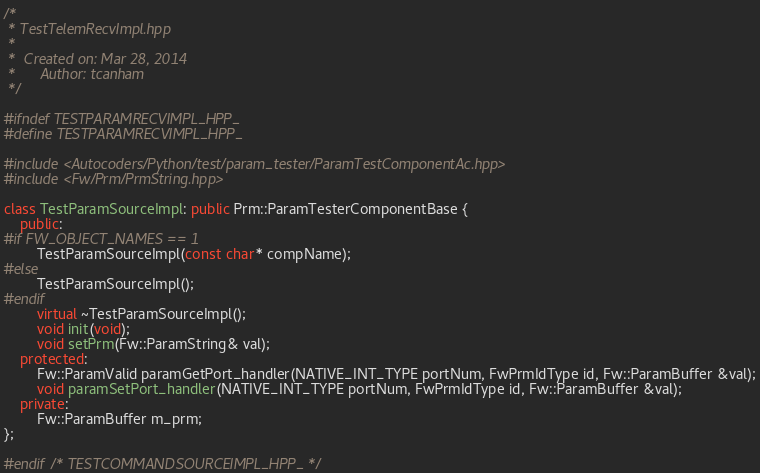<code> <loc_0><loc_0><loc_500><loc_500><_C++_>/*
 * TestTelemRecvImpl.hpp
 *
 *  Created on: Mar 28, 2014
 *      Author: tcanham
 */

#ifndef TESTPARAMRECVIMPL_HPP_
#define TESTPARAMRECVIMPL_HPP_

#include <Autocoders/Python/test/param_tester/ParamTestComponentAc.hpp>
#include <Fw/Prm/PrmString.hpp>

class TestParamSourceImpl: public Prm::ParamTesterComponentBase {
    public:
#if FW_OBJECT_NAMES == 1
        TestParamSourceImpl(const char* compName);
#else
        TestParamSourceImpl();
#endif
        virtual ~TestParamSourceImpl();
        void init(void);
        void setPrm(Fw::ParamString& val);
    protected:
        Fw::ParamValid paramGetPort_handler(NATIVE_INT_TYPE portNum, FwPrmIdType id, Fw::ParamBuffer &val);
        void paramSetPort_handler(NATIVE_INT_TYPE portNum, FwPrmIdType id, Fw::ParamBuffer &val);
    private:
        Fw::ParamBuffer m_prm;
};

#endif /* TESTCOMMANDSOURCEIMPL_HPP_ */
</code> 